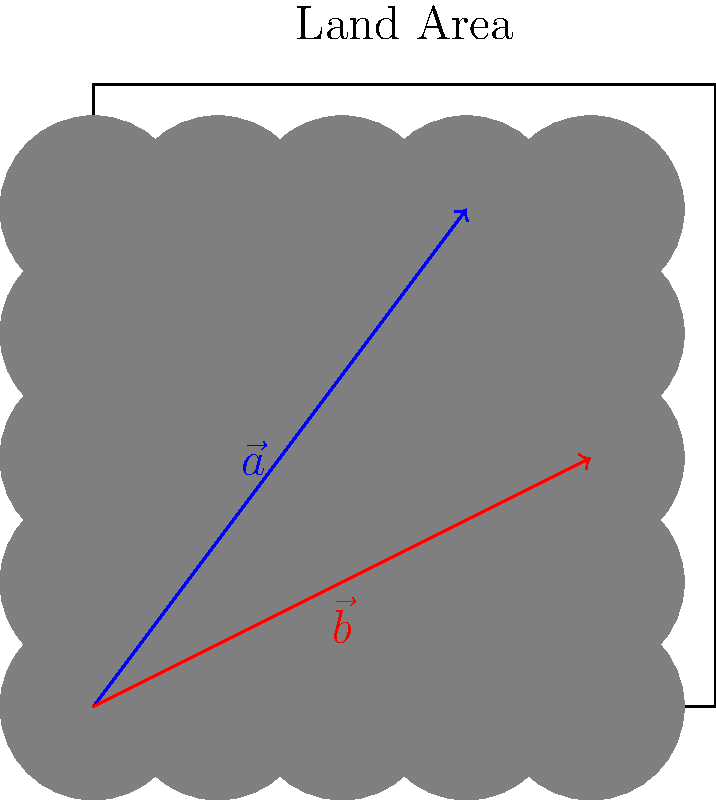A rectangular land area is being considered for a solar panel installation. Two vectors, $\vec{a} = 60\hat{i} + 80\hat{j}$ and $\vec{b} = 80\hat{i} + 40\hat{j}$, represent potential configurations for arranging solar panel arrays. Calculate the area of the parallelogram formed by these vectors, which represents the coverage area difference between the two configurations. To find the area of the parallelogram formed by vectors $\vec{a}$ and $\vec{b}$, we can use the magnitude of the cross product of these vectors. The steps are as follows:

1) The formula for the area of a parallelogram using cross product is:
   Area = $|\vec{a} \times \vec{b}|$

2) The cross product of two 2D vectors $\vec{a} = (a_x, a_y)$ and $\vec{b} = (b_x, b_y)$ is:
   $\vec{a} \times \vec{b} = a_x b_y - a_y b_x$

3) Substituting the given values:
   $\vec{a} = 60\hat{i} + 80\hat{j}$
   $\vec{b} = 80\hat{i} + 40\hat{j}$

4) Calculate the cross product:
   $\vec{a} \times \vec{b} = (60 \cdot 40) - (80 \cdot 80) = 2400 - 6400 = -4000$

5) The area is the absolute value of this result:
   Area = $|-4000| = 4000$

Therefore, the area of the parallelogram, representing the coverage area difference between the two configurations, is 4000 square units.
Answer: 4000 square units 